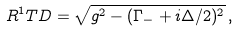Convert formula to latex. <formula><loc_0><loc_0><loc_500><loc_500>R ^ { 1 } T D = \sqrt { g ^ { 2 } - ( \Gamma _ { - } + i \Delta / 2 ) ^ { 2 } } \, ,</formula> 